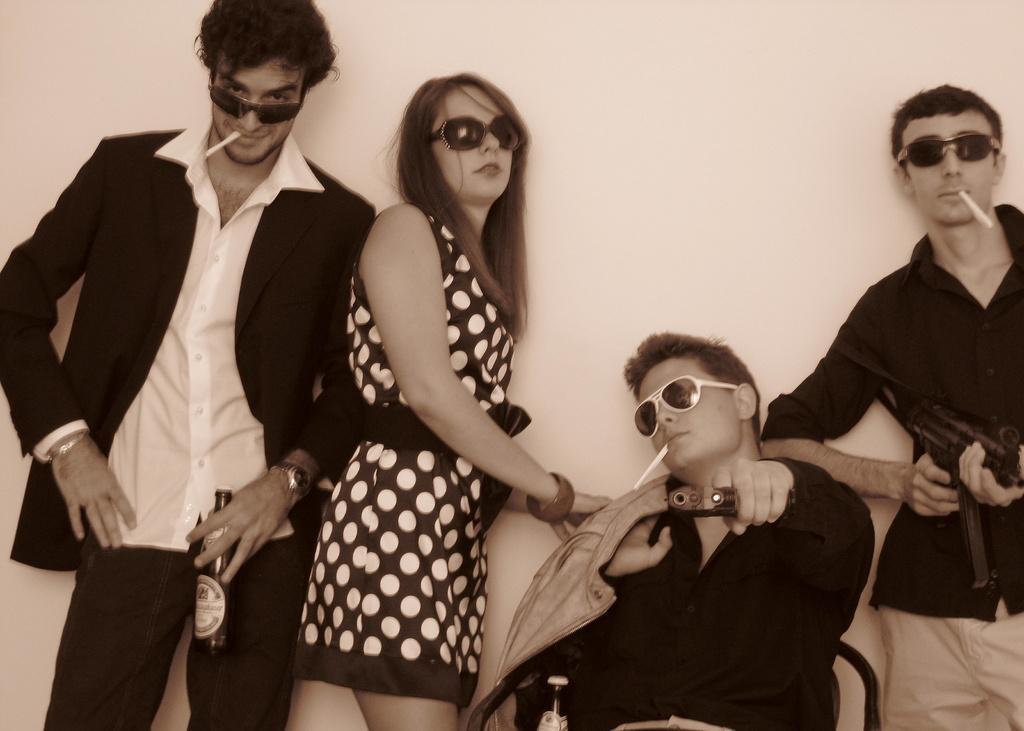Please provide a concise description of this image. In this image there are four people wearing goggles in which one of them is sitting on the chair, three of them are holding rolled paper in their mouth, bottles and the wall. 